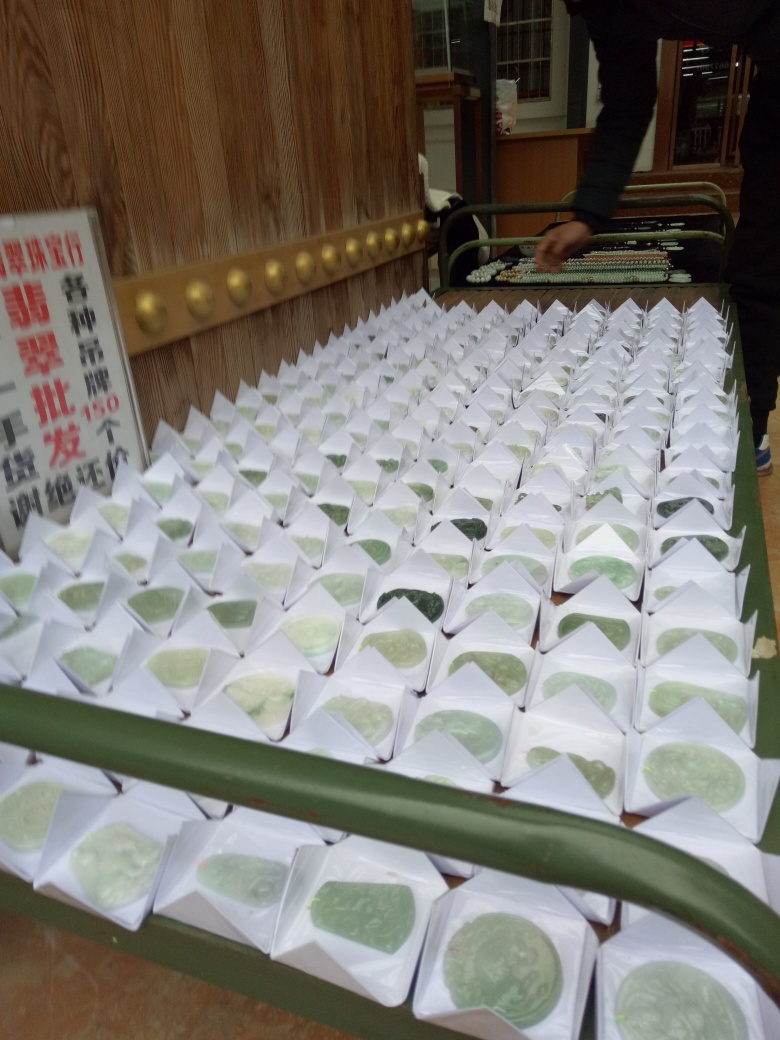What types of items are displayed in this photograph and what might their contents be? The photograph displays a large number of white packages, each containing a greenish item that resembles a type of food, perhaps mochi or a similar rice-based treat. The uniformity in packaging suggests these might be part of a commercial display or sale. 